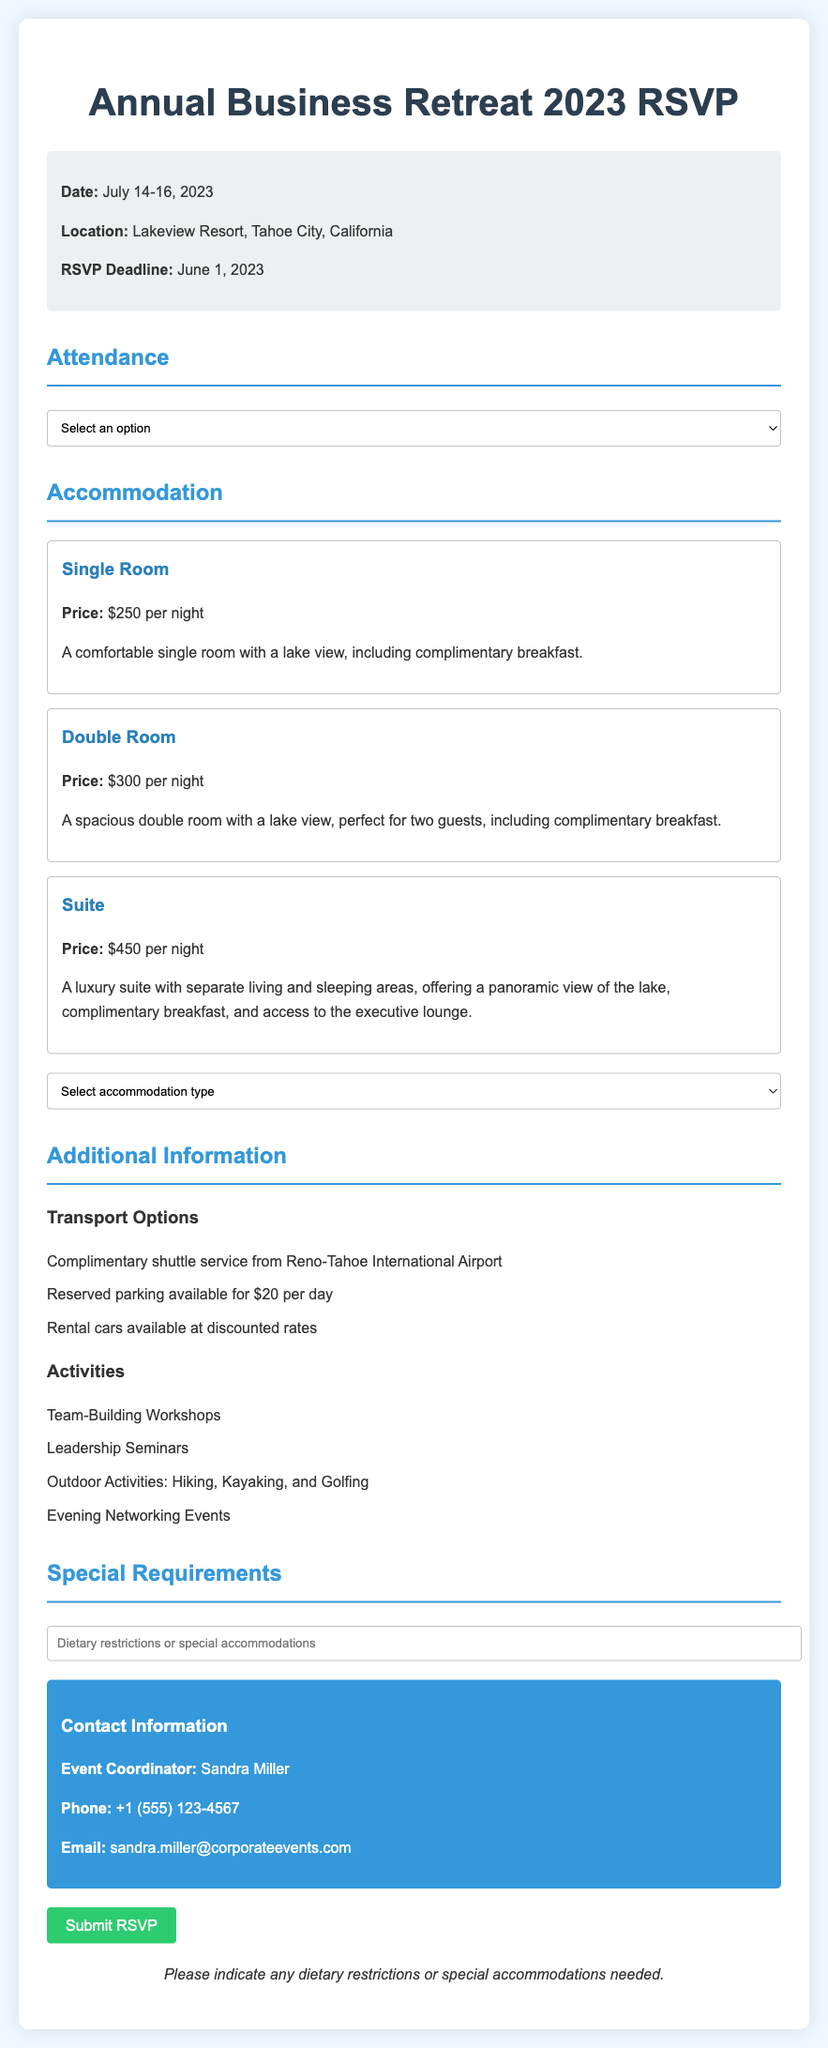What is the date of the Annual Business Retreat? The date of the retreat is explicitly stated in the document.
Answer: July 14-16, 2023 Where is the retreat taking place? The location of the retreat is mentioned in the document.
Answer: Lakeview Resort, Tahoe City, California What is the RSVP deadline? The deadline for RSVP submissions is noted in the document.
Answer: June 1, 2023 What is the price of a Single Room? The price information for accommodation types is detailed in the document.
Answer: $250 per night What transportation options are available? The document lists the transport options for attending the event.
Answer: Complimentary shuttle service What types of activities are included in the retreat? The document outlines the various activities planned for the retreat.
Answer: Team-Building Workshops If I select a Double Room, how much will it cost for one night? The price for a Double Room is specified in the accommodation section of the document.
Answer: $300 per night Who is the event coordinator? The name of the contact person for the event is provided in the document.
Answer: Sandra Miller What should be indicated if there are special requirements? The document prompts attendees to specify any special needs in a designated section.
Answer: Dietary restrictions or special accommodations 